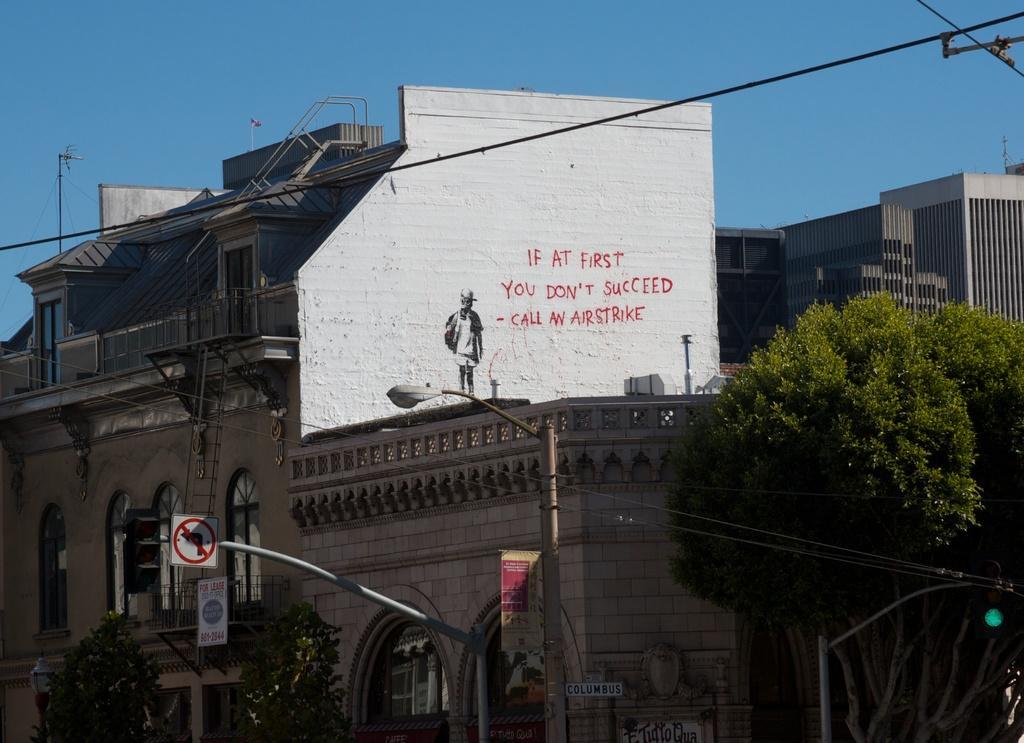Could you give a brief overview of what you see in this image? In this picture there are two poles in the center. Behind them there is a building with some text and a picture. At the bottom and at the bottom right, there are trees. On the top there is a sky and a wire. 